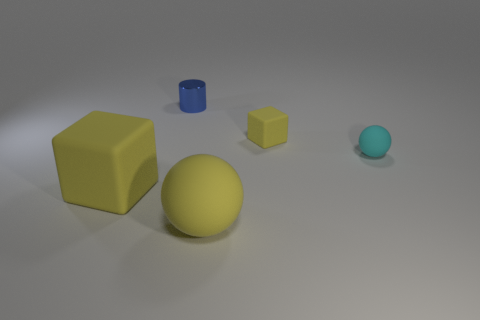Add 2 green cylinders. How many objects exist? 7 Subtract all cylinders. How many objects are left? 4 Subtract 0 cyan cylinders. How many objects are left? 5 Subtract all gray cubes. Subtract all cyan rubber spheres. How many objects are left? 4 Add 5 cyan things. How many cyan things are left? 6 Add 3 large yellow matte balls. How many large yellow matte balls exist? 4 